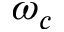<formula> <loc_0><loc_0><loc_500><loc_500>\omega _ { c }</formula> 